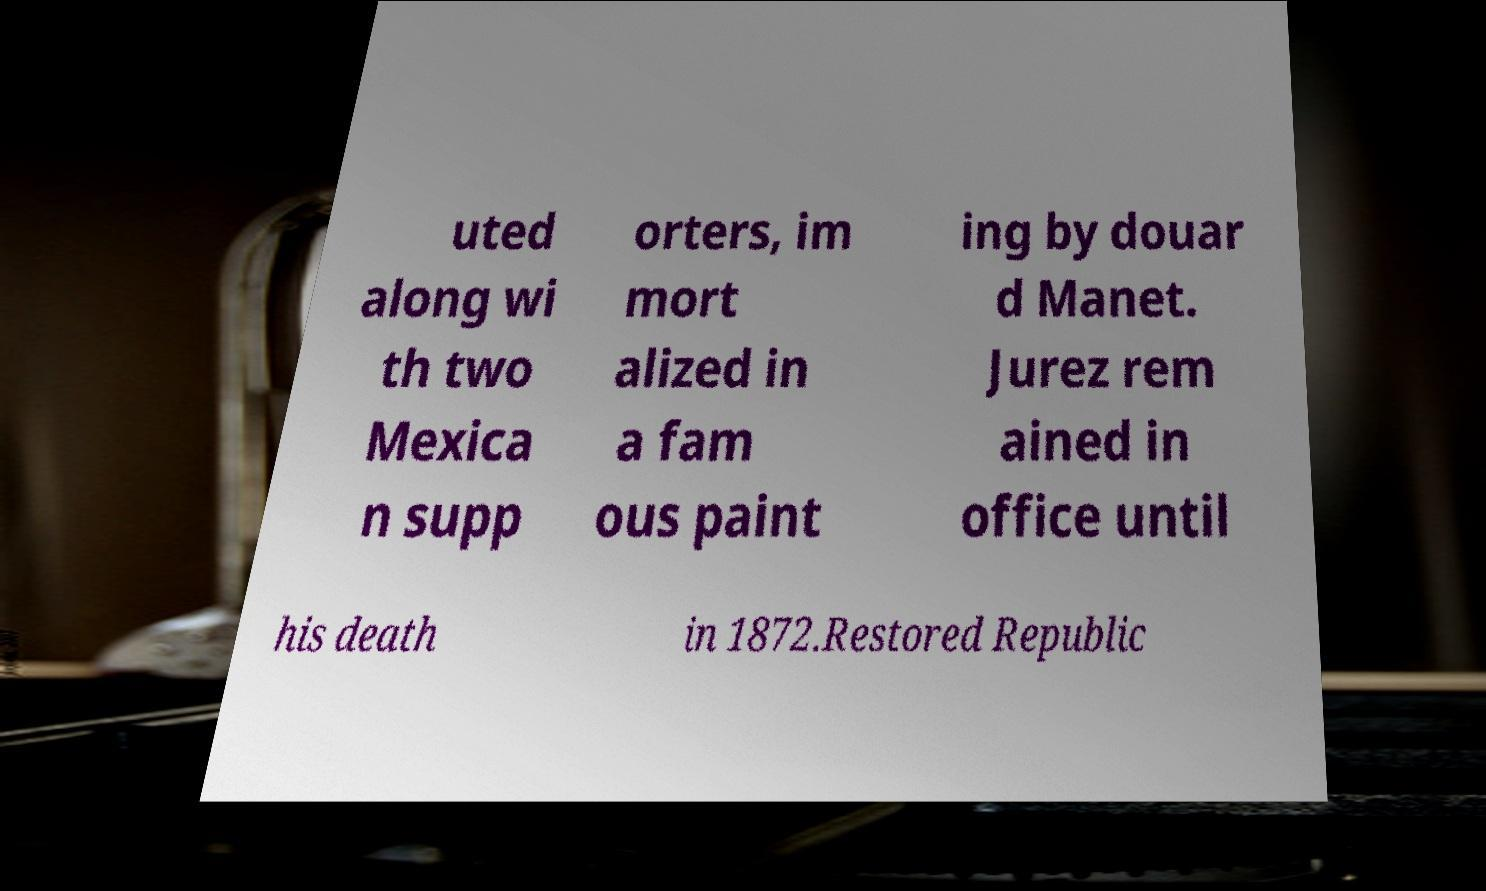What messages or text are displayed in this image? I need them in a readable, typed format. uted along wi th two Mexica n supp orters, im mort alized in a fam ous paint ing by douar d Manet. Jurez rem ained in office until his death in 1872.Restored Republic 